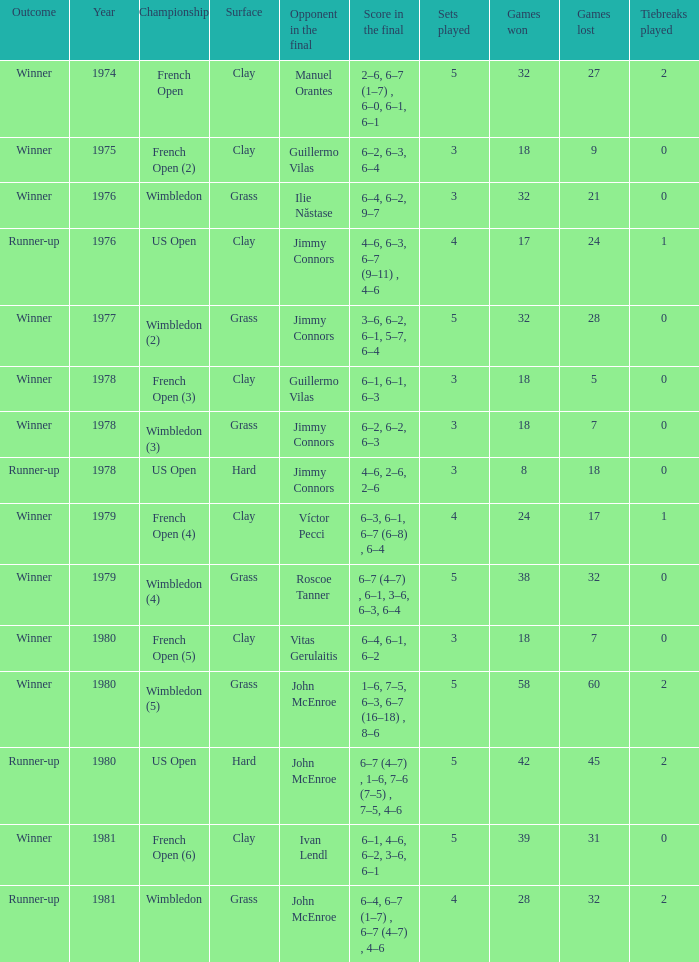What is every surface with a score in the final of 6–4, 6–7 (1–7) , 6–7 (4–7) , 4–6? Grass. 